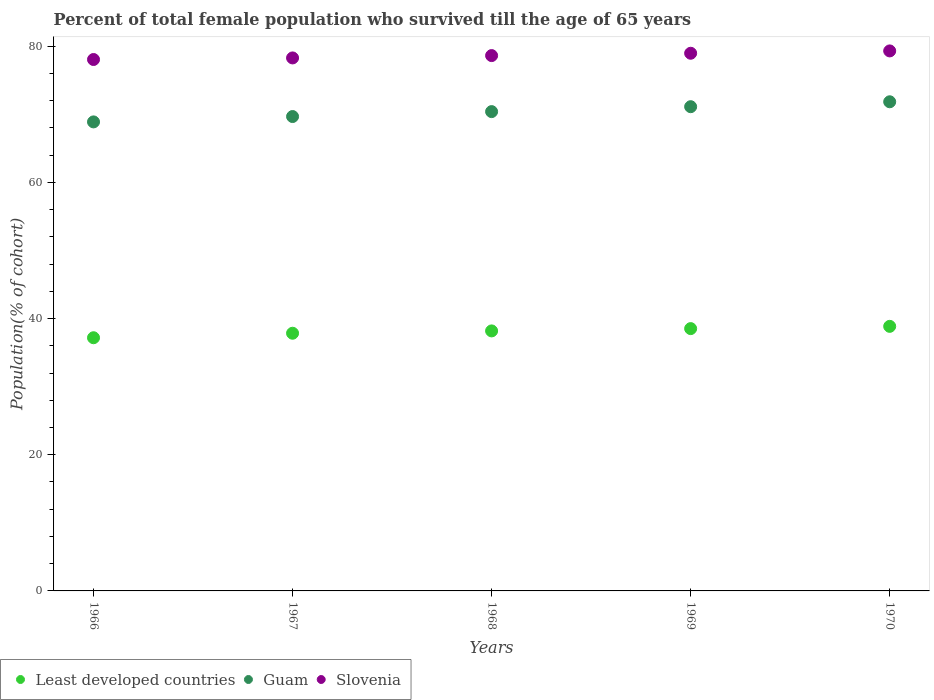How many different coloured dotlines are there?
Your response must be concise. 3. Is the number of dotlines equal to the number of legend labels?
Your answer should be very brief. Yes. What is the percentage of total female population who survived till the age of 65 years in Guam in 1968?
Your answer should be compact. 70.39. Across all years, what is the maximum percentage of total female population who survived till the age of 65 years in Slovenia?
Provide a succinct answer. 79.3. Across all years, what is the minimum percentage of total female population who survived till the age of 65 years in Least developed countries?
Offer a very short reply. 37.18. In which year was the percentage of total female population who survived till the age of 65 years in Slovenia maximum?
Your answer should be compact. 1970. In which year was the percentage of total female population who survived till the age of 65 years in Least developed countries minimum?
Your response must be concise. 1966. What is the total percentage of total female population who survived till the age of 65 years in Guam in the graph?
Provide a short and direct response. 351.88. What is the difference between the percentage of total female population who survived till the age of 65 years in Guam in 1967 and that in 1969?
Give a very brief answer. -1.44. What is the difference between the percentage of total female population who survived till the age of 65 years in Slovenia in 1966 and the percentage of total female population who survived till the age of 65 years in Guam in 1968?
Give a very brief answer. 7.65. What is the average percentage of total female population who survived till the age of 65 years in Least developed countries per year?
Your response must be concise. 38.12. In the year 1967, what is the difference between the percentage of total female population who survived till the age of 65 years in Guam and percentage of total female population who survived till the age of 65 years in Least developed countries?
Make the answer very short. 31.82. In how many years, is the percentage of total female population who survived till the age of 65 years in Least developed countries greater than 76 %?
Give a very brief answer. 0. What is the ratio of the percentage of total female population who survived till the age of 65 years in Least developed countries in 1966 to that in 1967?
Provide a succinct answer. 0.98. Is the percentage of total female population who survived till the age of 65 years in Slovenia in 1967 less than that in 1970?
Your answer should be compact. Yes. What is the difference between the highest and the second highest percentage of total female population who survived till the age of 65 years in Slovenia?
Offer a terse response. 0.34. What is the difference between the highest and the lowest percentage of total female population who survived till the age of 65 years in Guam?
Ensure brevity in your answer.  2.95. Is it the case that in every year, the sum of the percentage of total female population who survived till the age of 65 years in Slovenia and percentage of total female population who survived till the age of 65 years in Least developed countries  is greater than the percentage of total female population who survived till the age of 65 years in Guam?
Keep it short and to the point. Yes. Is the percentage of total female population who survived till the age of 65 years in Least developed countries strictly greater than the percentage of total female population who survived till the age of 65 years in Guam over the years?
Your answer should be very brief. No. Is the percentage of total female population who survived till the age of 65 years in Guam strictly less than the percentage of total female population who survived till the age of 65 years in Least developed countries over the years?
Your response must be concise. No. How many dotlines are there?
Your answer should be very brief. 3. How many years are there in the graph?
Your response must be concise. 5. What is the difference between two consecutive major ticks on the Y-axis?
Keep it short and to the point. 20. Does the graph contain any zero values?
Your answer should be very brief. No. Does the graph contain grids?
Give a very brief answer. No. Where does the legend appear in the graph?
Your answer should be compact. Bottom left. How are the legend labels stacked?
Offer a very short reply. Horizontal. What is the title of the graph?
Ensure brevity in your answer.  Percent of total female population who survived till the age of 65 years. Does "Angola" appear as one of the legend labels in the graph?
Ensure brevity in your answer.  No. What is the label or title of the Y-axis?
Your answer should be very brief. Population(% of cohort). What is the Population(% of cohort) in Least developed countries in 1966?
Offer a very short reply. 37.18. What is the Population(% of cohort) of Guam in 1966?
Provide a succinct answer. 68.88. What is the Population(% of cohort) of Slovenia in 1966?
Offer a terse response. 78.04. What is the Population(% of cohort) of Least developed countries in 1967?
Keep it short and to the point. 37.84. What is the Population(% of cohort) of Guam in 1967?
Keep it short and to the point. 69.67. What is the Population(% of cohort) in Slovenia in 1967?
Your answer should be compact. 78.27. What is the Population(% of cohort) of Least developed countries in 1968?
Your answer should be compact. 38.19. What is the Population(% of cohort) in Guam in 1968?
Make the answer very short. 70.39. What is the Population(% of cohort) of Slovenia in 1968?
Provide a succinct answer. 78.62. What is the Population(% of cohort) of Least developed countries in 1969?
Your answer should be compact. 38.52. What is the Population(% of cohort) of Guam in 1969?
Ensure brevity in your answer.  71.11. What is the Population(% of cohort) in Slovenia in 1969?
Your response must be concise. 78.96. What is the Population(% of cohort) in Least developed countries in 1970?
Your response must be concise. 38.85. What is the Population(% of cohort) of Guam in 1970?
Your answer should be very brief. 71.83. What is the Population(% of cohort) in Slovenia in 1970?
Keep it short and to the point. 79.3. Across all years, what is the maximum Population(% of cohort) of Least developed countries?
Ensure brevity in your answer.  38.85. Across all years, what is the maximum Population(% of cohort) in Guam?
Offer a terse response. 71.83. Across all years, what is the maximum Population(% of cohort) in Slovenia?
Provide a succinct answer. 79.3. Across all years, what is the minimum Population(% of cohort) in Least developed countries?
Ensure brevity in your answer.  37.18. Across all years, what is the minimum Population(% of cohort) of Guam?
Give a very brief answer. 68.88. Across all years, what is the minimum Population(% of cohort) in Slovenia?
Make the answer very short. 78.04. What is the total Population(% of cohort) in Least developed countries in the graph?
Offer a terse response. 190.59. What is the total Population(% of cohort) in Guam in the graph?
Provide a short and direct response. 351.88. What is the total Population(% of cohort) of Slovenia in the graph?
Provide a short and direct response. 393.2. What is the difference between the Population(% of cohort) in Least developed countries in 1966 and that in 1967?
Make the answer very short. -0.66. What is the difference between the Population(% of cohort) of Guam in 1966 and that in 1967?
Offer a very short reply. -0.79. What is the difference between the Population(% of cohort) in Slovenia in 1966 and that in 1967?
Offer a terse response. -0.23. What is the difference between the Population(% of cohort) in Least developed countries in 1966 and that in 1968?
Your response must be concise. -1. What is the difference between the Population(% of cohort) of Guam in 1966 and that in 1968?
Your answer should be compact. -1.51. What is the difference between the Population(% of cohort) in Slovenia in 1966 and that in 1968?
Provide a succinct answer. -0.58. What is the difference between the Population(% of cohort) of Least developed countries in 1966 and that in 1969?
Offer a very short reply. -1.34. What is the difference between the Population(% of cohort) in Guam in 1966 and that in 1969?
Give a very brief answer. -2.23. What is the difference between the Population(% of cohort) in Slovenia in 1966 and that in 1969?
Your answer should be very brief. -0.92. What is the difference between the Population(% of cohort) in Least developed countries in 1966 and that in 1970?
Make the answer very short. -1.67. What is the difference between the Population(% of cohort) of Guam in 1966 and that in 1970?
Keep it short and to the point. -2.95. What is the difference between the Population(% of cohort) of Slovenia in 1966 and that in 1970?
Provide a short and direct response. -1.26. What is the difference between the Population(% of cohort) in Least developed countries in 1967 and that in 1968?
Ensure brevity in your answer.  -0.34. What is the difference between the Population(% of cohort) in Guam in 1967 and that in 1968?
Provide a succinct answer. -0.72. What is the difference between the Population(% of cohort) of Slovenia in 1967 and that in 1968?
Keep it short and to the point. -0.34. What is the difference between the Population(% of cohort) in Least developed countries in 1967 and that in 1969?
Offer a terse response. -0.68. What is the difference between the Population(% of cohort) of Guam in 1967 and that in 1969?
Make the answer very short. -1.44. What is the difference between the Population(% of cohort) in Slovenia in 1967 and that in 1969?
Your answer should be compact. -0.69. What is the difference between the Population(% of cohort) in Least developed countries in 1967 and that in 1970?
Provide a succinct answer. -1.01. What is the difference between the Population(% of cohort) of Guam in 1967 and that in 1970?
Make the answer very short. -2.17. What is the difference between the Population(% of cohort) of Slovenia in 1967 and that in 1970?
Keep it short and to the point. -1.03. What is the difference between the Population(% of cohort) in Least developed countries in 1968 and that in 1969?
Provide a succinct answer. -0.34. What is the difference between the Population(% of cohort) of Guam in 1968 and that in 1969?
Give a very brief answer. -0.72. What is the difference between the Population(% of cohort) in Slovenia in 1968 and that in 1969?
Ensure brevity in your answer.  -0.34. What is the difference between the Population(% of cohort) in Least developed countries in 1968 and that in 1970?
Offer a terse response. -0.67. What is the difference between the Population(% of cohort) of Guam in 1968 and that in 1970?
Make the answer very short. -1.44. What is the difference between the Population(% of cohort) of Slovenia in 1968 and that in 1970?
Your answer should be very brief. -0.69. What is the difference between the Population(% of cohort) in Least developed countries in 1969 and that in 1970?
Your answer should be very brief. -0.33. What is the difference between the Population(% of cohort) of Guam in 1969 and that in 1970?
Your response must be concise. -0.72. What is the difference between the Population(% of cohort) in Slovenia in 1969 and that in 1970?
Ensure brevity in your answer.  -0.34. What is the difference between the Population(% of cohort) of Least developed countries in 1966 and the Population(% of cohort) of Guam in 1967?
Your response must be concise. -32.49. What is the difference between the Population(% of cohort) of Least developed countries in 1966 and the Population(% of cohort) of Slovenia in 1967?
Offer a terse response. -41.09. What is the difference between the Population(% of cohort) of Guam in 1966 and the Population(% of cohort) of Slovenia in 1967?
Your answer should be very brief. -9.39. What is the difference between the Population(% of cohort) in Least developed countries in 1966 and the Population(% of cohort) in Guam in 1968?
Keep it short and to the point. -33.21. What is the difference between the Population(% of cohort) of Least developed countries in 1966 and the Population(% of cohort) of Slovenia in 1968?
Provide a succinct answer. -41.44. What is the difference between the Population(% of cohort) in Guam in 1966 and the Population(% of cohort) in Slovenia in 1968?
Your answer should be compact. -9.74. What is the difference between the Population(% of cohort) of Least developed countries in 1966 and the Population(% of cohort) of Guam in 1969?
Offer a terse response. -33.93. What is the difference between the Population(% of cohort) in Least developed countries in 1966 and the Population(% of cohort) in Slovenia in 1969?
Offer a terse response. -41.78. What is the difference between the Population(% of cohort) in Guam in 1966 and the Population(% of cohort) in Slovenia in 1969?
Your answer should be compact. -10.08. What is the difference between the Population(% of cohort) of Least developed countries in 1966 and the Population(% of cohort) of Guam in 1970?
Give a very brief answer. -34.65. What is the difference between the Population(% of cohort) in Least developed countries in 1966 and the Population(% of cohort) in Slovenia in 1970?
Keep it short and to the point. -42.12. What is the difference between the Population(% of cohort) in Guam in 1966 and the Population(% of cohort) in Slovenia in 1970?
Your response must be concise. -10.42. What is the difference between the Population(% of cohort) of Least developed countries in 1967 and the Population(% of cohort) of Guam in 1968?
Provide a succinct answer. -32.55. What is the difference between the Population(% of cohort) in Least developed countries in 1967 and the Population(% of cohort) in Slovenia in 1968?
Ensure brevity in your answer.  -40.77. What is the difference between the Population(% of cohort) of Guam in 1967 and the Population(% of cohort) of Slovenia in 1968?
Make the answer very short. -8.95. What is the difference between the Population(% of cohort) of Least developed countries in 1967 and the Population(% of cohort) of Guam in 1969?
Keep it short and to the point. -33.27. What is the difference between the Population(% of cohort) in Least developed countries in 1967 and the Population(% of cohort) in Slovenia in 1969?
Ensure brevity in your answer.  -41.12. What is the difference between the Population(% of cohort) of Guam in 1967 and the Population(% of cohort) of Slovenia in 1969?
Provide a succinct answer. -9.29. What is the difference between the Population(% of cohort) in Least developed countries in 1967 and the Population(% of cohort) in Guam in 1970?
Offer a very short reply. -33.99. What is the difference between the Population(% of cohort) of Least developed countries in 1967 and the Population(% of cohort) of Slovenia in 1970?
Ensure brevity in your answer.  -41.46. What is the difference between the Population(% of cohort) of Guam in 1967 and the Population(% of cohort) of Slovenia in 1970?
Your response must be concise. -9.64. What is the difference between the Population(% of cohort) in Least developed countries in 1968 and the Population(% of cohort) in Guam in 1969?
Offer a terse response. -32.93. What is the difference between the Population(% of cohort) in Least developed countries in 1968 and the Population(% of cohort) in Slovenia in 1969?
Your answer should be compact. -40.78. What is the difference between the Population(% of cohort) of Guam in 1968 and the Population(% of cohort) of Slovenia in 1969?
Make the answer very short. -8.57. What is the difference between the Population(% of cohort) of Least developed countries in 1968 and the Population(% of cohort) of Guam in 1970?
Keep it short and to the point. -33.65. What is the difference between the Population(% of cohort) of Least developed countries in 1968 and the Population(% of cohort) of Slovenia in 1970?
Give a very brief answer. -41.12. What is the difference between the Population(% of cohort) of Guam in 1968 and the Population(% of cohort) of Slovenia in 1970?
Your response must be concise. -8.91. What is the difference between the Population(% of cohort) of Least developed countries in 1969 and the Population(% of cohort) of Guam in 1970?
Ensure brevity in your answer.  -33.31. What is the difference between the Population(% of cohort) in Least developed countries in 1969 and the Population(% of cohort) in Slovenia in 1970?
Make the answer very short. -40.78. What is the difference between the Population(% of cohort) in Guam in 1969 and the Population(% of cohort) in Slovenia in 1970?
Keep it short and to the point. -8.19. What is the average Population(% of cohort) of Least developed countries per year?
Keep it short and to the point. 38.12. What is the average Population(% of cohort) in Guam per year?
Make the answer very short. 70.38. What is the average Population(% of cohort) of Slovenia per year?
Your response must be concise. 78.64. In the year 1966, what is the difference between the Population(% of cohort) of Least developed countries and Population(% of cohort) of Guam?
Give a very brief answer. -31.7. In the year 1966, what is the difference between the Population(% of cohort) of Least developed countries and Population(% of cohort) of Slovenia?
Offer a terse response. -40.86. In the year 1966, what is the difference between the Population(% of cohort) in Guam and Population(% of cohort) in Slovenia?
Provide a succinct answer. -9.16. In the year 1967, what is the difference between the Population(% of cohort) of Least developed countries and Population(% of cohort) of Guam?
Keep it short and to the point. -31.82. In the year 1967, what is the difference between the Population(% of cohort) in Least developed countries and Population(% of cohort) in Slovenia?
Keep it short and to the point. -40.43. In the year 1967, what is the difference between the Population(% of cohort) of Guam and Population(% of cohort) of Slovenia?
Provide a succinct answer. -8.61. In the year 1968, what is the difference between the Population(% of cohort) of Least developed countries and Population(% of cohort) of Guam?
Offer a very short reply. -32.2. In the year 1968, what is the difference between the Population(% of cohort) of Least developed countries and Population(% of cohort) of Slovenia?
Keep it short and to the point. -40.43. In the year 1968, what is the difference between the Population(% of cohort) in Guam and Population(% of cohort) in Slovenia?
Make the answer very short. -8.23. In the year 1969, what is the difference between the Population(% of cohort) in Least developed countries and Population(% of cohort) in Guam?
Your answer should be very brief. -32.59. In the year 1969, what is the difference between the Population(% of cohort) in Least developed countries and Population(% of cohort) in Slovenia?
Your answer should be very brief. -40.44. In the year 1969, what is the difference between the Population(% of cohort) in Guam and Population(% of cohort) in Slovenia?
Your response must be concise. -7.85. In the year 1970, what is the difference between the Population(% of cohort) of Least developed countries and Population(% of cohort) of Guam?
Give a very brief answer. -32.98. In the year 1970, what is the difference between the Population(% of cohort) in Least developed countries and Population(% of cohort) in Slovenia?
Ensure brevity in your answer.  -40.45. In the year 1970, what is the difference between the Population(% of cohort) of Guam and Population(% of cohort) of Slovenia?
Provide a succinct answer. -7.47. What is the ratio of the Population(% of cohort) in Least developed countries in 1966 to that in 1967?
Offer a terse response. 0.98. What is the ratio of the Population(% of cohort) of Guam in 1966 to that in 1967?
Make the answer very short. 0.99. What is the ratio of the Population(% of cohort) of Slovenia in 1966 to that in 1967?
Your answer should be very brief. 1. What is the ratio of the Population(% of cohort) of Least developed countries in 1966 to that in 1968?
Keep it short and to the point. 0.97. What is the ratio of the Population(% of cohort) in Guam in 1966 to that in 1968?
Provide a short and direct response. 0.98. What is the ratio of the Population(% of cohort) of Least developed countries in 1966 to that in 1969?
Your answer should be very brief. 0.97. What is the ratio of the Population(% of cohort) of Guam in 1966 to that in 1969?
Offer a very short reply. 0.97. What is the ratio of the Population(% of cohort) in Slovenia in 1966 to that in 1969?
Make the answer very short. 0.99. What is the ratio of the Population(% of cohort) of Least developed countries in 1966 to that in 1970?
Provide a succinct answer. 0.96. What is the ratio of the Population(% of cohort) of Guam in 1966 to that in 1970?
Make the answer very short. 0.96. What is the ratio of the Population(% of cohort) in Slovenia in 1966 to that in 1970?
Provide a succinct answer. 0.98. What is the ratio of the Population(% of cohort) of Least developed countries in 1967 to that in 1968?
Provide a succinct answer. 0.99. What is the ratio of the Population(% of cohort) in Guam in 1967 to that in 1968?
Your answer should be very brief. 0.99. What is the ratio of the Population(% of cohort) in Slovenia in 1967 to that in 1968?
Your answer should be very brief. 1. What is the ratio of the Population(% of cohort) in Least developed countries in 1967 to that in 1969?
Your response must be concise. 0.98. What is the ratio of the Population(% of cohort) in Guam in 1967 to that in 1969?
Your answer should be compact. 0.98. What is the ratio of the Population(% of cohort) of Least developed countries in 1967 to that in 1970?
Keep it short and to the point. 0.97. What is the ratio of the Population(% of cohort) in Guam in 1967 to that in 1970?
Your answer should be compact. 0.97. What is the ratio of the Population(% of cohort) in Slovenia in 1967 to that in 1970?
Give a very brief answer. 0.99. What is the ratio of the Population(% of cohort) in Guam in 1968 to that in 1969?
Provide a succinct answer. 0.99. What is the ratio of the Population(% of cohort) in Slovenia in 1968 to that in 1969?
Keep it short and to the point. 1. What is the ratio of the Population(% of cohort) of Least developed countries in 1968 to that in 1970?
Your response must be concise. 0.98. What is the ratio of the Population(% of cohort) of Guam in 1968 to that in 1970?
Keep it short and to the point. 0.98. What is the ratio of the Population(% of cohort) of Least developed countries in 1969 to that in 1970?
Keep it short and to the point. 0.99. What is the ratio of the Population(% of cohort) in Slovenia in 1969 to that in 1970?
Provide a short and direct response. 1. What is the difference between the highest and the second highest Population(% of cohort) of Least developed countries?
Make the answer very short. 0.33. What is the difference between the highest and the second highest Population(% of cohort) of Guam?
Provide a succinct answer. 0.72. What is the difference between the highest and the second highest Population(% of cohort) of Slovenia?
Your response must be concise. 0.34. What is the difference between the highest and the lowest Population(% of cohort) in Least developed countries?
Offer a very short reply. 1.67. What is the difference between the highest and the lowest Population(% of cohort) of Guam?
Offer a terse response. 2.95. What is the difference between the highest and the lowest Population(% of cohort) in Slovenia?
Provide a succinct answer. 1.26. 